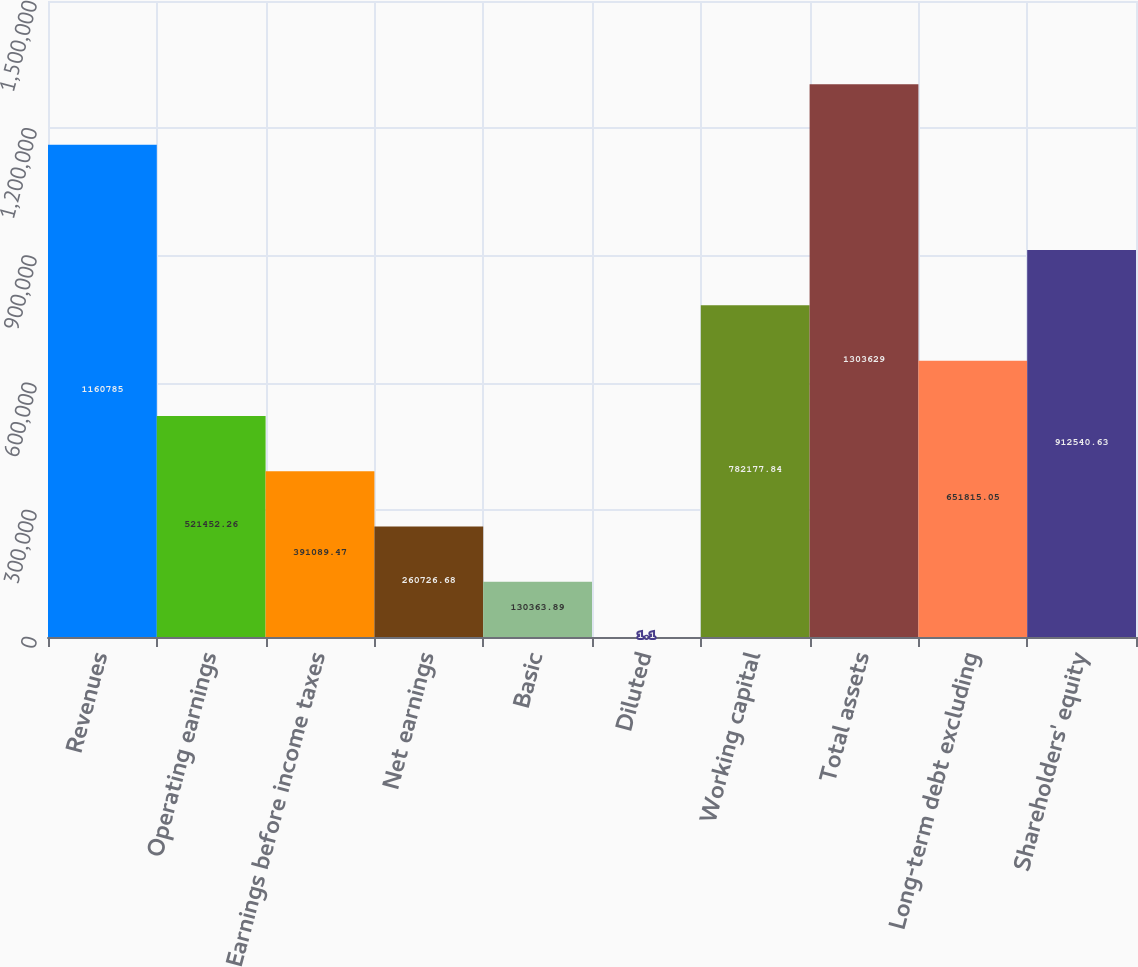<chart> <loc_0><loc_0><loc_500><loc_500><bar_chart><fcel>Revenues<fcel>Operating earnings<fcel>Earnings before income taxes<fcel>Net earnings<fcel>Basic<fcel>Diluted<fcel>Working capital<fcel>Total assets<fcel>Long-term debt excluding<fcel>Shareholders' equity<nl><fcel>1.16078e+06<fcel>521452<fcel>391089<fcel>260727<fcel>130364<fcel>1.1<fcel>782178<fcel>1.30363e+06<fcel>651815<fcel>912541<nl></chart> 